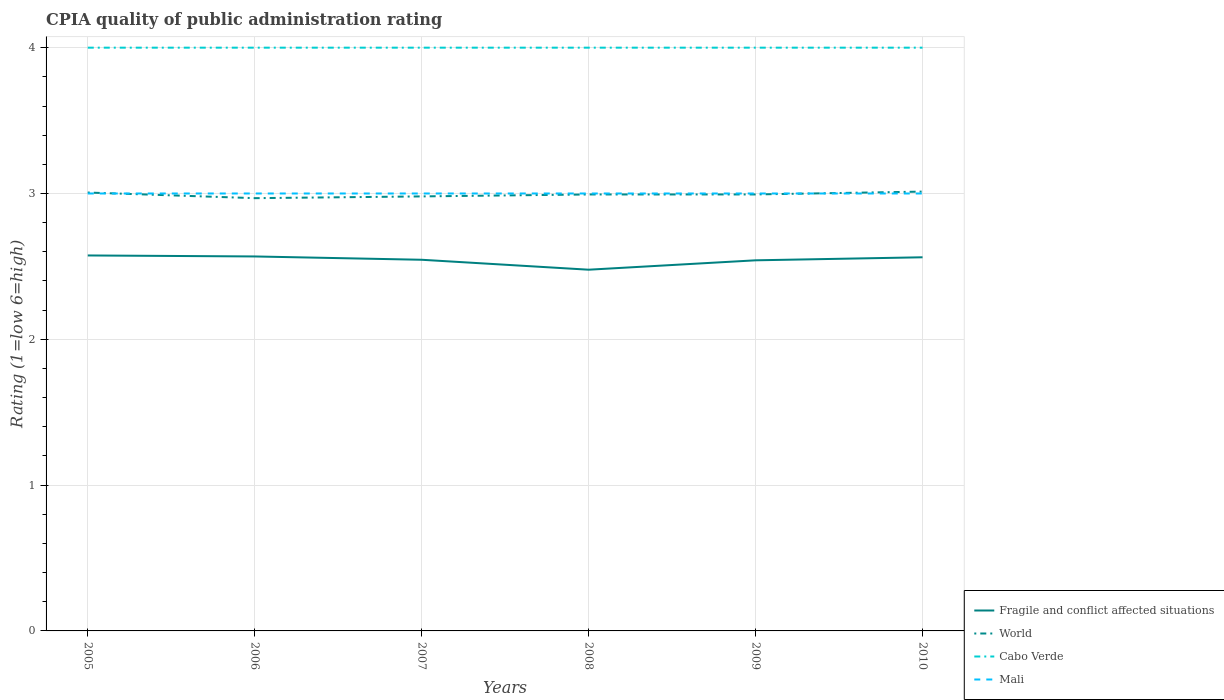How many different coloured lines are there?
Make the answer very short. 4. Does the line corresponding to Cabo Verde intersect with the line corresponding to World?
Your response must be concise. No. Is the number of lines equal to the number of legend labels?
Your answer should be very brief. Yes. Across all years, what is the maximum CPIA rating in Fragile and conflict affected situations?
Your answer should be very brief. 2.48. What is the total CPIA rating in Fragile and conflict affected situations in the graph?
Ensure brevity in your answer.  0.03. What is the difference between the highest and the second highest CPIA rating in Mali?
Offer a terse response. 0. What is the difference between the highest and the lowest CPIA rating in Fragile and conflict affected situations?
Keep it short and to the point. 4. How many lines are there?
Make the answer very short. 4. How many years are there in the graph?
Provide a succinct answer. 6. What is the difference between two consecutive major ticks on the Y-axis?
Offer a very short reply. 1. Does the graph contain grids?
Your response must be concise. Yes. Where does the legend appear in the graph?
Provide a succinct answer. Bottom right. How many legend labels are there?
Give a very brief answer. 4. What is the title of the graph?
Keep it short and to the point. CPIA quality of public administration rating. Does "Poland" appear as one of the legend labels in the graph?
Give a very brief answer. No. What is the label or title of the Y-axis?
Give a very brief answer. Rating (1=low 6=high). What is the Rating (1=low 6=high) in Fragile and conflict affected situations in 2005?
Your answer should be compact. 2.58. What is the Rating (1=low 6=high) in World in 2005?
Offer a very short reply. 3.01. What is the Rating (1=low 6=high) in Fragile and conflict affected situations in 2006?
Offer a terse response. 2.57. What is the Rating (1=low 6=high) in World in 2006?
Offer a very short reply. 2.97. What is the Rating (1=low 6=high) of Fragile and conflict affected situations in 2007?
Keep it short and to the point. 2.55. What is the Rating (1=low 6=high) in World in 2007?
Offer a very short reply. 2.98. What is the Rating (1=low 6=high) in Fragile and conflict affected situations in 2008?
Ensure brevity in your answer.  2.48. What is the Rating (1=low 6=high) in World in 2008?
Provide a short and direct response. 2.99. What is the Rating (1=low 6=high) of Cabo Verde in 2008?
Make the answer very short. 4. What is the Rating (1=low 6=high) of Mali in 2008?
Give a very brief answer. 3. What is the Rating (1=low 6=high) in Fragile and conflict affected situations in 2009?
Your answer should be compact. 2.54. What is the Rating (1=low 6=high) in World in 2009?
Offer a terse response. 2.99. What is the Rating (1=low 6=high) in Cabo Verde in 2009?
Provide a short and direct response. 4. What is the Rating (1=low 6=high) in Fragile and conflict affected situations in 2010?
Your answer should be compact. 2.56. What is the Rating (1=low 6=high) in World in 2010?
Offer a terse response. 3.01. Across all years, what is the maximum Rating (1=low 6=high) in Fragile and conflict affected situations?
Your answer should be very brief. 2.58. Across all years, what is the maximum Rating (1=low 6=high) of World?
Provide a succinct answer. 3.01. Across all years, what is the maximum Rating (1=low 6=high) in Mali?
Your answer should be compact. 3. Across all years, what is the minimum Rating (1=low 6=high) in Fragile and conflict affected situations?
Keep it short and to the point. 2.48. Across all years, what is the minimum Rating (1=low 6=high) of World?
Keep it short and to the point. 2.97. Across all years, what is the minimum Rating (1=low 6=high) of Mali?
Offer a very short reply. 3. What is the total Rating (1=low 6=high) of Fragile and conflict affected situations in the graph?
Your answer should be very brief. 15.27. What is the total Rating (1=low 6=high) of World in the graph?
Ensure brevity in your answer.  17.95. What is the difference between the Rating (1=low 6=high) in Fragile and conflict affected situations in 2005 and that in 2006?
Keep it short and to the point. 0.01. What is the difference between the Rating (1=low 6=high) of World in 2005 and that in 2006?
Keep it short and to the point. 0.04. What is the difference between the Rating (1=low 6=high) in Cabo Verde in 2005 and that in 2006?
Make the answer very short. 0. What is the difference between the Rating (1=low 6=high) in Mali in 2005 and that in 2006?
Offer a very short reply. 0. What is the difference between the Rating (1=low 6=high) of Fragile and conflict affected situations in 2005 and that in 2007?
Ensure brevity in your answer.  0.03. What is the difference between the Rating (1=low 6=high) of World in 2005 and that in 2007?
Your answer should be compact. 0.03. What is the difference between the Rating (1=low 6=high) in Fragile and conflict affected situations in 2005 and that in 2008?
Offer a terse response. 0.1. What is the difference between the Rating (1=low 6=high) of World in 2005 and that in 2008?
Ensure brevity in your answer.  0.01. What is the difference between the Rating (1=low 6=high) of Mali in 2005 and that in 2008?
Offer a very short reply. 0. What is the difference between the Rating (1=low 6=high) in World in 2005 and that in 2009?
Provide a succinct answer. 0.01. What is the difference between the Rating (1=low 6=high) in Cabo Verde in 2005 and that in 2009?
Offer a terse response. 0. What is the difference between the Rating (1=low 6=high) of Fragile and conflict affected situations in 2005 and that in 2010?
Ensure brevity in your answer.  0.01. What is the difference between the Rating (1=low 6=high) of World in 2005 and that in 2010?
Your answer should be compact. -0.01. What is the difference between the Rating (1=low 6=high) in Cabo Verde in 2005 and that in 2010?
Keep it short and to the point. 0. What is the difference between the Rating (1=low 6=high) of Fragile and conflict affected situations in 2006 and that in 2007?
Provide a succinct answer. 0.02. What is the difference between the Rating (1=low 6=high) in World in 2006 and that in 2007?
Provide a succinct answer. -0.01. What is the difference between the Rating (1=low 6=high) of Mali in 2006 and that in 2007?
Give a very brief answer. 0. What is the difference between the Rating (1=low 6=high) in Fragile and conflict affected situations in 2006 and that in 2008?
Your answer should be very brief. 0.09. What is the difference between the Rating (1=low 6=high) of World in 2006 and that in 2008?
Offer a terse response. -0.03. What is the difference between the Rating (1=low 6=high) of Cabo Verde in 2006 and that in 2008?
Keep it short and to the point. 0. What is the difference between the Rating (1=low 6=high) of Fragile and conflict affected situations in 2006 and that in 2009?
Make the answer very short. 0.03. What is the difference between the Rating (1=low 6=high) of World in 2006 and that in 2009?
Your answer should be very brief. -0.03. What is the difference between the Rating (1=low 6=high) in Cabo Verde in 2006 and that in 2009?
Ensure brevity in your answer.  0. What is the difference between the Rating (1=low 6=high) in Fragile and conflict affected situations in 2006 and that in 2010?
Give a very brief answer. 0.01. What is the difference between the Rating (1=low 6=high) in World in 2006 and that in 2010?
Ensure brevity in your answer.  -0.04. What is the difference between the Rating (1=low 6=high) of Cabo Verde in 2006 and that in 2010?
Make the answer very short. 0. What is the difference between the Rating (1=low 6=high) of Fragile and conflict affected situations in 2007 and that in 2008?
Give a very brief answer. 0.07. What is the difference between the Rating (1=low 6=high) of World in 2007 and that in 2008?
Provide a succinct answer. -0.01. What is the difference between the Rating (1=low 6=high) of Fragile and conflict affected situations in 2007 and that in 2009?
Your answer should be very brief. 0. What is the difference between the Rating (1=low 6=high) in World in 2007 and that in 2009?
Keep it short and to the point. -0.01. What is the difference between the Rating (1=low 6=high) in Mali in 2007 and that in 2009?
Ensure brevity in your answer.  0. What is the difference between the Rating (1=low 6=high) of Fragile and conflict affected situations in 2007 and that in 2010?
Your answer should be very brief. -0.02. What is the difference between the Rating (1=low 6=high) in World in 2007 and that in 2010?
Your answer should be compact. -0.03. What is the difference between the Rating (1=low 6=high) of Cabo Verde in 2007 and that in 2010?
Offer a terse response. 0. What is the difference between the Rating (1=low 6=high) of Fragile and conflict affected situations in 2008 and that in 2009?
Give a very brief answer. -0.06. What is the difference between the Rating (1=low 6=high) of World in 2008 and that in 2009?
Ensure brevity in your answer.  -0. What is the difference between the Rating (1=low 6=high) in Cabo Verde in 2008 and that in 2009?
Your answer should be very brief. 0. What is the difference between the Rating (1=low 6=high) of Fragile and conflict affected situations in 2008 and that in 2010?
Provide a short and direct response. -0.09. What is the difference between the Rating (1=low 6=high) in World in 2008 and that in 2010?
Provide a short and direct response. -0.02. What is the difference between the Rating (1=low 6=high) of Cabo Verde in 2008 and that in 2010?
Keep it short and to the point. 0. What is the difference between the Rating (1=low 6=high) in Fragile and conflict affected situations in 2009 and that in 2010?
Make the answer very short. -0.02. What is the difference between the Rating (1=low 6=high) of World in 2009 and that in 2010?
Provide a short and direct response. -0.02. What is the difference between the Rating (1=low 6=high) of Cabo Verde in 2009 and that in 2010?
Your answer should be compact. 0. What is the difference between the Rating (1=low 6=high) of Mali in 2009 and that in 2010?
Provide a short and direct response. 0. What is the difference between the Rating (1=low 6=high) of Fragile and conflict affected situations in 2005 and the Rating (1=low 6=high) of World in 2006?
Your response must be concise. -0.39. What is the difference between the Rating (1=low 6=high) in Fragile and conflict affected situations in 2005 and the Rating (1=low 6=high) in Cabo Verde in 2006?
Offer a very short reply. -1.43. What is the difference between the Rating (1=low 6=high) of Fragile and conflict affected situations in 2005 and the Rating (1=low 6=high) of Mali in 2006?
Offer a very short reply. -0.42. What is the difference between the Rating (1=low 6=high) in World in 2005 and the Rating (1=low 6=high) in Cabo Verde in 2006?
Your response must be concise. -0.99. What is the difference between the Rating (1=low 6=high) of World in 2005 and the Rating (1=low 6=high) of Mali in 2006?
Provide a succinct answer. 0.01. What is the difference between the Rating (1=low 6=high) in Cabo Verde in 2005 and the Rating (1=low 6=high) in Mali in 2006?
Offer a very short reply. 1. What is the difference between the Rating (1=low 6=high) of Fragile and conflict affected situations in 2005 and the Rating (1=low 6=high) of World in 2007?
Offer a very short reply. -0.41. What is the difference between the Rating (1=low 6=high) in Fragile and conflict affected situations in 2005 and the Rating (1=low 6=high) in Cabo Verde in 2007?
Give a very brief answer. -1.43. What is the difference between the Rating (1=low 6=high) of Fragile and conflict affected situations in 2005 and the Rating (1=low 6=high) of Mali in 2007?
Your response must be concise. -0.42. What is the difference between the Rating (1=low 6=high) of World in 2005 and the Rating (1=low 6=high) of Cabo Verde in 2007?
Keep it short and to the point. -0.99. What is the difference between the Rating (1=low 6=high) of World in 2005 and the Rating (1=low 6=high) of Mali in 2007?
Ensure brevity in your answer.  0.01. What is the difference between the Rating (1=low 6=high) of Fragile and conflict affected situations in 2005 and the Rating (1=low 6=high) of World in 2008?
Your response must be concise. -0.42. What is the difference between the Rating (1=low 6=high) of Fragile and conflict affected situations in 2005 and the Rating (1=low 6=high) of Cabo Verde in 2008?
Make the answer very short. -1.43. What is the difference between the Rating (1=low 6=high) of Fragile and conflict affected situations in 2005 and the Rating (1=low 6=high) of Mali in 2008?
Your answer should be very brief. -0.42. What is the difference between the Rating (1=low 6=high) in World in 2005 and the Rating (1=low 6=high) in Cabo Verde in 2008?
Provide a short and direct response. -0.99. What is the difference between the Rating (1=low 6=high) of World in 2005 and the Rating (1=low 6=high) of Mali in 2008?
Make the answer very short. 0.01. What is the difference between the Rating (1=low 6=high) in Cabo Verde in 2005 and the Rating (1=low 6=high) in Mali in 2008?
Make the answer very short. 1. What is the difference between the Rating (1=low 6=high) in Fragile and conflict affected situations in 2005 and the Rating (1=low 6=high) in World in 2009?
Offer a very short reply. -0.42. What is the difference between the Rating (1=low 6=high) in Fragile and conflict affected situations in 2005 and the Rating (1=low 6=high) in Cabo Verde in 2009?
Your answer should be compact. -1.43. What is the difference between the Rating (1=low 6=high) of Fragile and conflict affected situations in 2005 and the Rating (1=low 6=high) of Mali in 2009?
Give a very brief answer. -0.42. What is the difference between the Rating (1=low 6=high) of World in 2005 and the Rating (1=low 6=high) of Cabo Verde in 2009?
Your response must be concise. -0.99. What is the difference between the Rating (1=low 6=high) of World in 2005 and the Rating (1=low 6=high) of Mali in 2009?
Keep it short and to the point. 0.01. What is the difference between the Rating (1=low 6=high) of Cabo Verde in 2005 and the Rating (1=low 6=high) of Mali in 2009?
Ensure brevity in your answer.  1. What is the difference between the Rating (1=low 6=high) in Fragile and conflict affected situations in 2005 and the Rating (1=low 6=high) in World in 2010?
Your answer should be compact. -0.44. What is the difference between the Rating (1=low 6=high) in Fragile and conflict affected situations in 2005 and the Rating (1=low 6=high) in Cabo Verde in 2010?
Your response must be concise. -1.43. What is the difference between the Rating (1=low 6=high) of Fragile and conflict affected situations in 2005 and the Rating (1=low 6=high) of Mali in 2010?
Your answer should be compact. -0.42. What is the difference between the Rating (1=low 6=high) in World in 2005 and the Rating (1=low 6=high) in Cabo Verde in 2010?
Provide a short and direct response. -0.99. What is the difference between the Rating (1=low 6=high) in World in 2005 and the Rating (1=low 6=high) in Mali in 2010?
Give a very brief answer. 0.01. What is the difference between the Rating (1=low 6=high) in Cabo Verde in 2005 and the Rating (1=low 6=high) in Mali in 2010?
Your answer should be compact. 1. What is the difference between the Rating (1=low 6=high) of Fragile and conflict affected situations in 2006 and the Rating (1=low 6=high) of World in 2007?
Provide a succinct answer. -0.41. What is the difference between the Rating (1=low 6=high) in Fragile and conflict affected situations in 2006 and the Rating (1=low 6=high) in Cabo Verde in 2007?
Give a very brief answer. -1.43. What is the difference between the Rating (1=low 6=high) in Fragile and conflict affected situations in 2006 and the Rating (1=low 6=high) in Mali in 2007?
Make the answer very short. -0.43. What is the difference between the Rating (1=low 6=high) of World in 2006 and the Rating (1=low 6=high) of Cabo Verde in 2007?
Offer a terse response. -1.03. What is the difference between the Rating (1=low 6=high) in World in 2006 and the Rating (1=low 6=high) in Mali in 2007?
Give a very brief answer. -0.03. What is the difference between the Rating (1=low 6=high) in Cabo Verde in 2006 and the Rating (1=low 6=high) in Mali in 2007?
Your answer should be very brief. 1. What is the difference between the Rating (1=low 6=high) of Fragile and conflict affected situations in 2006 and the Rating (1=low 6=high) of World in 2008?
Ensure brevity in your answer.  -0.43. What is the difference between the Rating (1=low 6=high) of Fragile and conflict affected situations in 2006 and the Rating (1=low 6=high) of Cabo Verde in 2008?
Your answer should be compact. -1.43. What is the difference between the Rating (1=low 6=high) in Fragile and conflict affected situations in 2006 and the Rating (1=low 6=high) in Mali in 2008?
Provide a short and direct response. -0.43. What is the difference between the Rating (1=low 6=high) of World in 2006 and the Rating (1=low 6=high) of Cabo Verde in 2008?
Your response must be concise. -1.03. What is the difference between the Rating (1=low 6=high) of World in 2006 and the Rating (1=low 6=high) of Mali in 2008?
Make the answer very short. -0.03. What is the difference between the Rating (1=low 6=high) of Fragile and conflict affected situations in 2006 and the Rating (1=low 6=high) of World in 2009?
Your answer should be compact. -0.43. What is the difference between the Rating (1=low 6=high) in Fragile and conflict affected situations in 2006 and the Rating (1=low 6=high) in Cabo Verde in 2009?
Provide a succinct answer. -1.43. What is the difference between the Rating (1=low 6=high) in Fragile and conflict affected situations in 2006 and the Rating (1=low 6=high) in Mali in 2009?
Provide a short and direct response. -0.43. What is the difference between the Rating (1=low 6=high) in World in 2006 and the Rating (1=low 6=high) in Cabo Verde in 2009?
Offer a very short reply. -1.03. What is the difference between the Rating (1=low 6=high) in World in 2006 and the Rating (1=low 6=high) in Mali in 2009?
Your answer should be very brief. -0.03. What is the difference between the Rating (1=low 6=high) in Cabo Verde in 2006 and the Rating (1=low 6=high) in Mali in 2009?
Offer a terse response. 1. What is the difference between the Rating (1=low 6=high) in Fragile and conflict affected situations in 2006 and the Rating (1=low 6=high) in World in 2010?
Keep it short and to the point. -0.44. What is the difference between the Rating (1=low 6=high) in Fragile and conflict affected situations in 2006 and the Rating (1=low 6=high) in Cabo Verde in 2010?
Your response must be concise. -1.43. What is the difference between the Rating (1=low 6=high) in Fragile and conflict affected situations in 2006 and the Rating (1=low 6=high) in Mali in 2010?
Offer a very short reply. -0.43. What is the difference between the Rating (1=low 6=high) in World in 2006 and the Rating (1=low 6=high) in Cabo Verde in 2010?
Keep it short and to the point. -1.03. What is the difference between the Rating (1=low 6=high) in World in 2006 and the Rating (1=low 6=high) in Mali in 2010?
Your answer should be compact. -0.03. What is the difference between the Rating (1=low 6=high) in Cabo Verde in 2006 and the Rating (1=low 6=high) in Mali in 2010?
Make the answer very short. 1. What is the difference between the Rating (1=low 6=high) of Fragile and conflict affected situations in 2007 and the Rating (1=low 6=high) of World in 2008?
Provide a short and direct response. -0.45. What is the difference between the Rating (1=low 6=high) in Fragile and conflict affected situations in 2007 and the Rating (1=low 6=high) in Cabo Verde in 2008?
Offer a very short reply. -1.45. What is the difference between the Rating (1=low 6=high) of Fragile and conflict affected situations in 2007 and the Rating (1=low 6=high) of Mali in 2008?
Your answer should be compact. -0.45. What is the difference between the Rating (1=low 6=high) in World in 2007 and the Rating (1=low 6=high) in Cabo Verde in 2008?
Keep it short and to the point. -1.02. What is the difference between the Rating (1=low 6=high) in World in 2007 and the Rating (1=low 6=high) in Mali in 2008?
Ensure brevity in your answer.  -0.02. What is the difference between the Rating (1=low 6=high) in Cabo Verde in 2007 and the Rating (1=low 6=high) in Mali in 2008?
Provide a succinct answer. 1. What is the difference between the Rating (1=low 6=high) of Fragile and conflict affected situations in 2007 and the Rating (1=low 6=high) of World in 2009?
Make the answer very short. -0.45. What is the difference between the Rating (1=low 6=high) in Fragile and conflict affected situations in 2007 and the Rating (1=low 6=high) in Cabo Verde in 2009?
Your answer should be very brief. -1.45. What is the difference between the Rating (1=low 6=high) in Fragile and conflict affected situations in 2007 and the Rating (1=low 6=high) in Mali in 2009?
Your response must be concise. -0.45. What is the difference between the Rating (1=low 6=high) in World in 2007 and the Rating (1=low 6=high) in Cabo Verde in 2009?
Make the answer very short. -1.02. What is the difference between the Rating (1=low 6=high) of World in 2007 and the Rating (1=low 6=high) of Mali in 2009?
Keep it short and to the point. -0.02. What is the difference between the Rating (1=low 6=high) in Cabo Verde in 2007 and the Rating (1=low 6=high) in Mali in 2009?
Ensure brevity in your answer.  1. What is the difference between the Rating (1=low 6=high) of Fragile and conflict affected situations in 2007 and the Rating (1=low 6=high) of World in 2010?
Your answer should be very brief. -0.47. What is the difference between the Rating (1=low 6=high) in Fragile and conflict affected situations in 2007 and the Rating (1=low 6=high) in Cabo Verde in 2010?
Make the answer very short. -1.45. What is the difference between the Rating (1=low 6=high) of Fragile and conflict affected situations in 2007 and the Rating (1=low 6=high) of Mali in 2010?
Offer a terse response. -0.45. What is the difference between the Rating (1=low 6=high) of World in 2007 and the Rating (1=low 6=high) of Cabo Verde in 2010?
Your answer should be very brief. -1.02. What is the difference between the Rating (1=low 6=high) of World in 2007 and the Rating (1=low 6=high) of Mali in 2010?
Your answer should be compact. -0.02. What is the difference between the Rating (1=low 6=high) in Cabo Verde in 2007 and the Rating (1=low 6=high) in Mali in 2010?
Your response must be concise. 1. What is the difference between the Rating (1=low 6=high) in Fragile and conflict affected situations in 2008 and the Rating (1=low 6=high) in World in 2009?
Ensure brevity in your answer.  -0.52. What is the difference between the Rating (1=low 6=high) of Fragile and conflict affected situations in 2008 and the Rating (1=low 6=high) of Cabo Verde in 2009?
Your response must be concise. -1.52. What is the difference between the Rating (1=low 6=high) of Fragile and conflict affected situations in 2008 and the Rating (1=low 6=high) of Mali in 2009?
Keep it short and to the point. -0.52. What is the difference between the Rating (1=low 6=high) of World in 2008 and the Rating (1=low 6=high) of Cabo Verde in 2009?
Your answer should be compact. -1.01. What is the difference between the Rating (1=low 6=high) in World in 2008 and the Rating (1=low 6=high) in Mali in 2009?
Provide a short and direct response. -0.01. What is the difference between the Rating (1=low 6=high) in Fragile and conflict affected situations in 2008 and the Rating (1=low 6=high) in World in 2010?
Your response must be concise. -0.54. What is the difference between the Rating (1=low 6=high) in Fragile and conflict affected situations in 2008 and the Rating (1=low 6=high) in Cabo Verde in 2010?
Your answer should be very brief. -1.52. What is the difference between the Rating (1=low 6=high) in Fragile and conflict affected situations in 2008 and the Rating (1=low 6=high) in Mali in 2010?
Offer a terse response. -0.52. What is the difference between the Rating (1=low 6=high) of World in 2008 and the Rating (1=low 6=high) of Cabo Verde in 2010?
Keep it short and to the point. -1.01. What is the difference between the Rating (1=low 6=high) of World in 2008 and the Rating (1=low 6=high) of Mali in 2010?
Your response must be concise. -0.01. What is the difference between the Rating (1=low 6=high) in Fragile and conflict affected situations in 2009 and the Rating (1=low 6=high) in World in 2010?
Ensure brevity in your answer.  -0.47. What is the difference between the Rating (1=low 6=high) of Fragile and conflict affected situations in 2009 and the Rating (1=low 6=high) of Cabo Verde in 2010?
Make the answer very short. -1.46. What is the difference between the Rating (1=low 6=high) of Fragile and conflict affected situations in 2009 and the Rating (1=low 6=high) of Mali in 2010?
Offer a terse response. -0.46. What is the difference between the Rating (1=low 6=high) in World in 2009 and the Rating (1=low 6=high) in Cabo Verde in 2010?
Give a very brief answer. -1.01. What is the difference between the Rating (1=low 6=high) of World in 2009 and the Rating (1=low 6=high) of Mali in 2010?
Make the answer very short. -0.01. What is the average Rating (1=low 6=high) in Fragile and conflict affected situations per year?
Offer a terse response. 2.54. What is the average Rating (1=low 6=high) of World per year?
Your answer should be very brief. 2.99. What is the average Rating (1=low 6=high) of Mali per year?
Provide a succinct answer. 3. In the year 2005, what is the difference between the Rating (1=low 6=high) of Fragile and conflict affected situations and Rating (1=low 6=high) of World?
Offer a terse response. -0.43. In the year 2005, what is the difference between the Rating (1=low 6=high) in Fragile and conflict affected situations and Rating (1=low 6=high) in Cabo Verde?
Make the answer very short. -1.43. In the year 2005, what is the difference between the Rating (1=low 6=high) in Fragile and conflict affected situations and Rating (1=low 6=high) in Mali?
Your response must be concise. -0.42. In the year 2005, what is the difference between the Rating (1=low 6=high) in World and Rating (1=low 6=high) in Cabo Verde?
Your answer should be very brief. -0.99. In the year 2005, what is the difference between the Rating (1=low 6=high) in World and Rating (1=low 6=high) in Mali?
Your response must be concise. 0.01. In the year 2006, what is the difference between the Rating (1=low 6=high) in Fragile and conflict affected situations and Rating (1=low 6=high) in World?
Provide a succinct answer. -0.4. In the year 2006, what is the difference between the Rating (1=low 6=high) in Fragile and conflict affected situations and Rating (1=low 6=high) in Cabo Verde?
Your answer should be very brief. -1.43. In the year 2006, what is the difference between the Rating (1=low 6=high) in Fragile and conflict affected situations and Rating (1=low 6=high) in Mali?
Offer a very short reply. -0.43. In the year 2006, what is the difference between the Rating (1=low 6=high) of World and Rating (1=low 6=high) of Cabo Verde?
Provide a succinct answer. -1.03. In the year 2006, what is the difference between the Rating (1=low 6=high) of World and Rating (1=low 6=high) of Mali?
Make the answer very short. -0.03. In the year 2006, what is the difference between the Rating (1=low 6=high) of Cabo Verde and Rating (1=low 6=high) of Mali?
Make the answer very short. 1. In the year 2007, what is the difference between the Rating (1=low 6=high) in Fragile and conflict affected situations and Rating (1=low 6=high) in World?
Keep it short and to the point. -0.43. In the year 2007, what is the difference between the Rating (1=low 6=high) of Fragile and conflict affected situations and Rating (1=low 6=high) of Cabo Verde?
Offer a very short reply. -1.45. In the year 2007, what is the difference between the Rating (1=low 6=high) of Fragile and conflict affected situations and Rating (1=low 6=high) of Mali?
Offer a very short reply. -0.45. In the year 2007, what is the difference between the Rating (1=low 6=high) of World and Rating (1=low 6=high) of Cabo Verde?
Provide a short and direct response. -1.02. In the year 2007, what is the difference between the Rating (1=low 6=high) in World and Rating (1=low 6=high) in Mali?
Your answer should be very brief. -0.02. In the year 2008, what is the difference between the Rating (1=low 6=high) in Fragile and conflict affected situations and Rating (1=low 6=high) in World?
Offer a terse response. -0.52. In the year 2008, what is the difference between the Rating (1=low 6=high) of Fragile and conflict affected situations and Rating (1=low 6=high) of Cabo Verde?
Your response must be concise. -1.52. In the year 2008, what is the difference between the Rating (1=low 6=high) of Fragile and conflict affected situations and Rating (1=low 6=high) of Mali?
Give a very brief answer. -0.52. In the year 2008, what is the difference between the Rating (1=low 6=high) of World and Rating (1=low 6=high) of Cabo Verde?
Your response must be concise. -1.01. In the year 2008, what is the difference between the Rating (1=low 6=high) in World and Rating (1=low 6=high) in Mali?
Your answer should be compact. -0.01. In the year 2009, what is the difference between the Rating (1=low 6=high) of Fragile and conflict affected situations and Rating (1=low 6=high) of World?
Your response must be concise. -0.45. In the year 2009, what is the difference between the Rating (1=low 6=high) of Fragile and conflict affected situations and Rating (1=low 6=high) of Cabo Verde?
Provide a succinct answer. -1.46. In the year 2009, what is the difference between the Rating (1=low 6=high) of Fragile and conflict affected situations and Rating (1=low 6=high) of Mali?
Provide a succinct answer. -0.46. In the year 2009, what is the difference between the Rating (1=low 6=high) in World and Rating (1=low 6=high) in Cabo Verde?
Provide a short and direct response. -1.01. In the year 2009, what is the difference between the Rating (1=low 6=high) in World and Rating (1=low 6=high) in Mali?
Ensure brevity in your answer.  -0.01. In the year 2010, what is the difference between the Rating (1=low 6=high) of Fragile and conflict affected situations and Rating (1=low 6=high) of World?
Your answer should be compact. -0.45. In the year 2010, what is the difference between the Rating (1=low 6=high) in Fragile and conflict affected situations and Rating (1=low 6=high) in Cabo Verde?
Offer a very short reply. -1.44. In the year 2010, what is the difference between the Rating (1=low 6=high) in Fragile and conflict affected situations and Rating (1=low 6=high) in Mali?
Offer a very short reply. -0.44. In the year 2010, what is the difference between the Rating (1=low 6=high) of World and Rating (1=low 6=high) of Cabo Verde?
Offer a terse response. -0.99. In the year 2010, what is the difference between the Rating (1=low 6=high) in World and Rating (1=low 6=high) in Mali?
Offer a terse response. 0.01. In the year 2010, what is the difference between the Rating (1=low 6=high) in Cabo Verde and Rating (1=low 6=high) in Mali?
Offer a terse response. 1. What is the ratio of the Rating (1=low 6=high) of World in 2005 to that in 2006?
Provide a short and direct response. 1.01. What is the ratio of the Rating (1=low 6=high) of Cabo Verde in 2005 to that in 2006?
Provide a short and direct response. 1. What is the ratio of the Rating (1=low 6=high) of Mali in 2005 to that in 2006?
Your answer should be compact. 1. What is the ratio of the Rating (1=low 6=high) in Fragile and conflict affected situations in 2005 to that in 2007?
Keep it short and to the point. 1.01. What is the ratio of the Rating (1=low 6=high) of World in 2005 to that in 2007?
Offer a terse response. 1.01. What is the ratio of the Rating (1=low 6=high) of Cabo Verde in 2005 to that in 2007?
Make the answer very short. 1. What is the ratio of the Rating (1=low 6=high) in Mali in 2005 to that in 2007?
Offer a very short reply. 1. What is the ratio of the Rating (1=low 6=high) of Fragile and conflict affected situations in 2005 to that in 2008?
Your answer should be compact. 1.04. What is the ratio of the Rating (1=low 6=high) in World in 2005 to that in 2008?
Give a very brief answer. 1. What is the ratio of the Rating (1=low 6=high) in Mali in 2005 to that in 2008?
Make the answer very short. 1. What is the ratio of the Rating (1=low 6=high) in Fragile and conflict affected situations in 2005 to that in 2009?
Ensure brevity in your answer.  1.01. What is the ratio of the Rating (1=low 6=high) of Mali in 2005 to that in 2009?
Provide a short and direct response. 1. What is the ratio of the Rating (1=low 6=high) of Cabo Verde in 2005 to that in 2010?
Ensure brevity in your answer.  1. What is the ratio of the Rating (1=low 6=high) of Mali in 2005 to that in 2010?
Your answer should be compact. 1. What is the ratio of the Rating (1=low 6=high) in Fragile and conflict affected situations in 2006 to that in 2007?
Provide a short and direct response. 1.01. What is the ratio of the Rating (1=low 6=high) in World in 2006 to that in 2007?
Make the answer very short. 1. What is the ratio of the Rating (1=low 6=high) of Cabo Verde in 2006 to that in 2007?
Your response must be concise. 1. What is the ratio of the Rating (1=low 6=high) in Fragile and conflict affected situations in 2006 to that in 2008?
Make the answer very short. 1.04. What is the ratio of the Rating (1=low 6=high) of Cabo Verde in 2006 to that in 2008?
Keep it short and to the point. 1. What is the ratio of the Rating (1=low 6=high) in Mali in 2006 to that in 2008?
Your response must be concise. 1. What is the ratio of the Rating (1=low 6=high) in Fragile and conflict affected situations in 2006 to that in 2009?
Your response must be concise. 1.01. What is the ratio of the Rating (1=low 6=high) in World in 2006 to that in 2009?
Make the answer very short. 0.99. What is the ratio of the Rating (1=low 6=high) in Cabo Verde in 2006 to that in 2009?
Offer a terse response. 1. What is the ratio of the Rating (1=low 6=high) in Fragile and conflict affected situations in 2006 to that in 2010?
Your answer should be compact. 1. What is the ratio of the Rating (1=low 6=high) of World in 2006 to that in 2010?
Ensure brevity in your answer.  0.99. What is the ratio of the Rating (1=low 6=high) of Fragile and conflict affected situations in 2007 to that in 2008?
Ensure brevity in your answer.  1.03. What is the ratio of the Rating (1=low 6=high) in Cabo Verde in 2007 to that in 2008?
Ensure brevity in your answer.  1. What is the ratio of the Rating (1=low 6=high) of Fragile and conflict affected situations in 2007 to that in 2009?
Keep it short and to the point. 1. What is the ratio of the Rating (1=low 6=high) of World in 2007 to that in 2009?
Give a very brief answer. 1. What is the ratio of the Rating (1=low 6=high) of Mali in 2007 to that in 2009?
Your response must be concise. 1. What is the ratio of the Rating (1=low 6=high) of World in 2007 to that in 2010?
Make the answer very short. 0.99. What is the ratio of the Rating (1=low 6=high) in Mali in 2007 to that in 2010?
Offer a very short reply. 1. What is the ratio of the Rating (1=low 6=high) of Fragile and conflict affected situations in 2008 to that in 2009?
Offer a terse response. 0.97. What is the ratio of the Rating (1=low 6=high) in Cabo Verde in 2008 to that in 2009?
Offer a very short reply. 1. What is the ratio of the Rating (1=low 6=high) of Fragile and conflict affected situations in 2008 to that in 2010?
Give a very brief answer. 0.97. What is the ratio of the Rating (1=low 6=high) of World in 2009 to that in 2010?
Your answer should be very brief. 0.99. What is the ratio of the Rating (1=low 6=high) of Mali in 2009 to that in 2010?
Ensure brevity in your answer.  1. What is the difference between the highest and the second highest Rating (1=low 6=high) of Fragile and conflict affected situations?
Offer a very short reply. 0.01. What is the difference between the highest and the second highest Rating (1=low 6=high) of World?
Offer a very short reply. 0.01. What is the difference between the highest and the second highest Rating (1=low 6=high) in Mali?
Make the answer very short. 0. What is the difference between the highest and the lowest Rating (1=low 6=high) in Fragile and conflict affected situations?
Provide a short and direct response. 0.1. What is the difference between the highest and the lowest Rating (1=low 6=high) of World?
Provide a succinct answer. 0.04. 